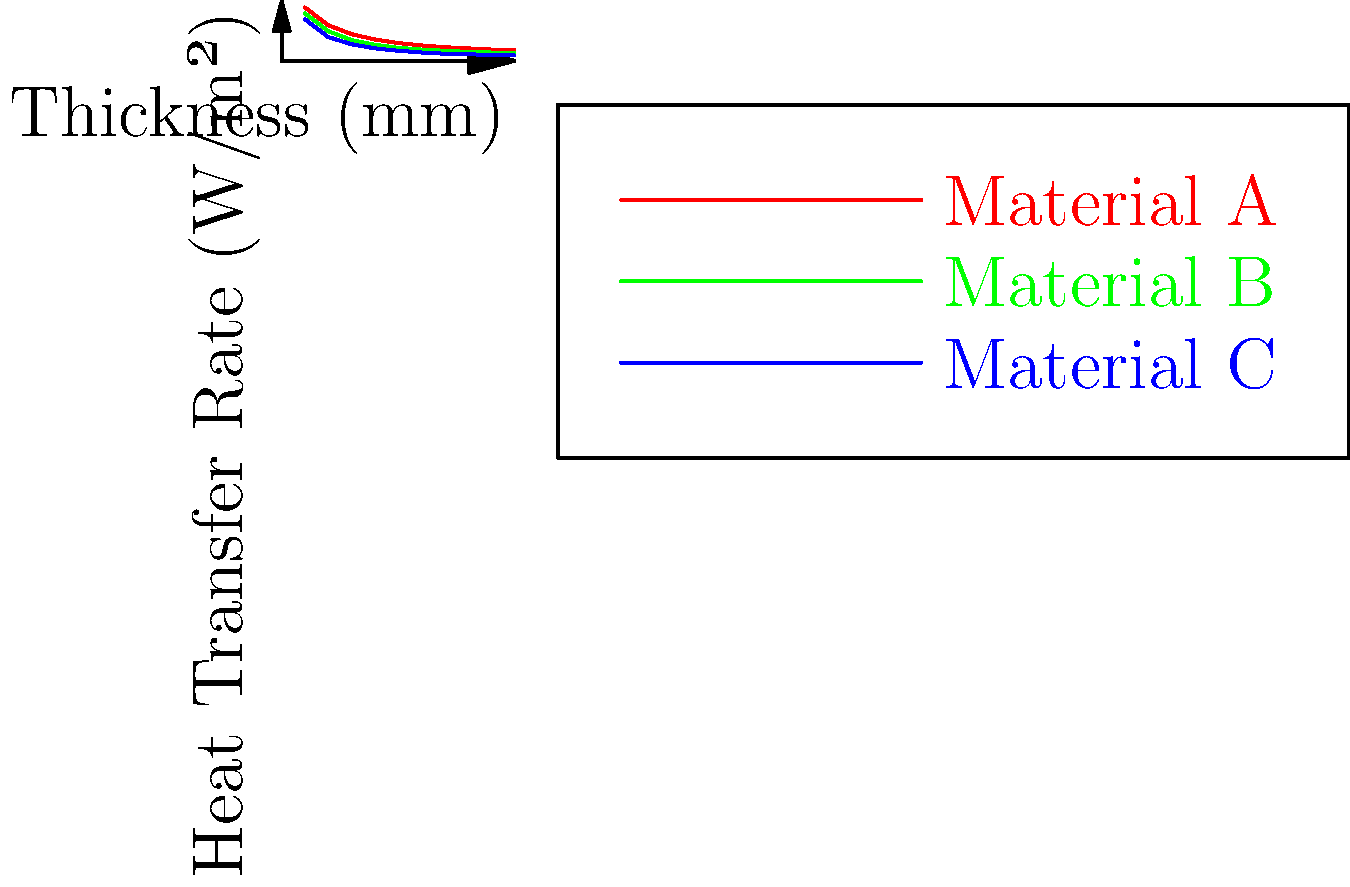In your latest abstract painting series inspired by thermal dynamics, you've created a piece representing heat transfer through various insulation materials. The graph shows the heat transfer rates for three different materials (A, B, and C) as their thickness increases. If you were to choose a material for insulating a superhero's high-tech suit to maintain optimal body temperature, which material would you select for a thickness of 50mm, and what would be its approximate heat transfer rate? To answer this question, we need to analyze the graph and follow these steps:

1. Locate the 50mm thickness on the x-axis.
2. For each material, find the corresponding heat transfer rate at 50mm:
   - Material A (red line): Approximately 150 W/m²
   - Material B (green line): Approximately 110 W/m²
   - Material C (blue line): Approximately 85 W/m²
3. Compare the heat transfer rates:
   - Lower heat transfer rate means better insulation
   - Material C has the lowest heat transfer rate at 50mm thickness
4. Select Material C as the best insulator for the superhero suit
5. The approximate heat transfer rate for Material C at 50mm is 85 W/m²

This choice would provide the best thermal insulation for the superhero suit, allowing for optimal temperature regulation while potentially inspiring new abstract art concepts blending science and superhero aesthetics.
Answer: Material C, 85 W/m² 